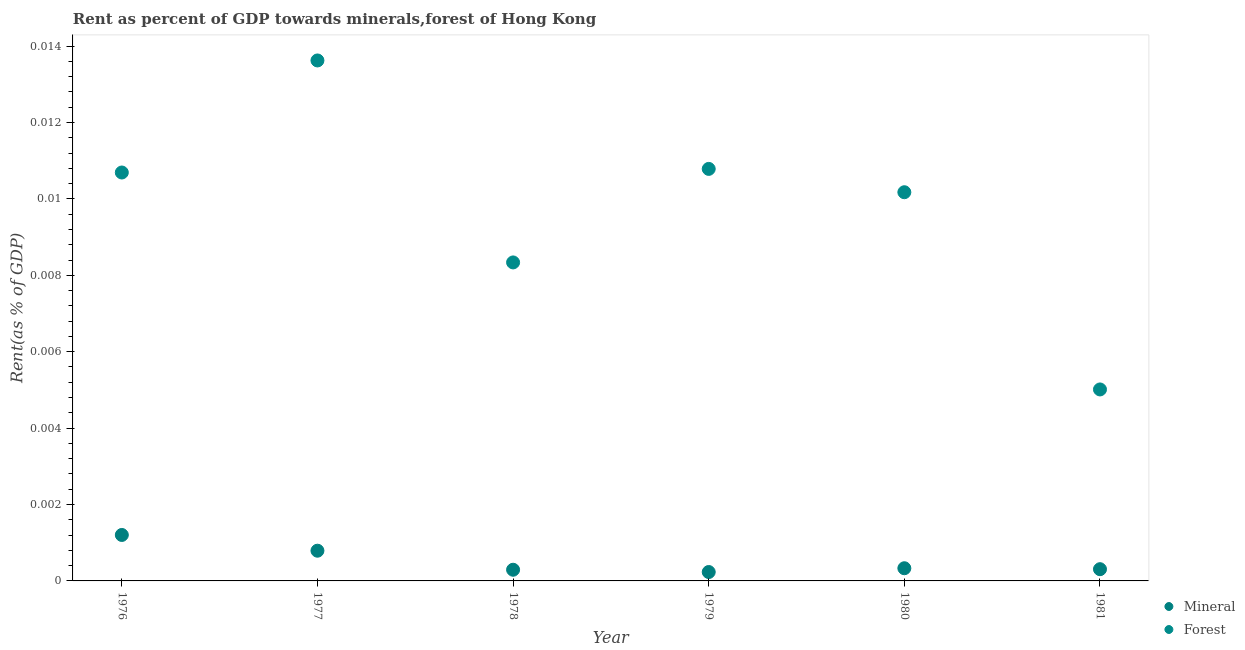How many different coloured dotlines are there?
Provide a succinct answer. 2. Is the number of dotlines equal to the number of legend labels?
Give a very brief answer. Yes. What is the forest rent in 1977?
Make the answer very short. 0.01. Across all years, what is the maximum mineral rent?
Offer a terse response. 0. Across all years, what is the minimum forest rent?
Make the answer very short. 0.01. What is the total mineral rent in the graph?
Give a very brief answer. 0. What is the difference between the mineral rent in 1978 and that in 1981?
Provide a short and direct response. -1.468707399487299e-5. What is the difference between the forest rent in 1978 and the mineral rent in 1980?
Ensure brevity in your answer.  0.01. What is the average forest rent per year?
Offer a terse response. 0.01. In the year 1981, what is the difference between the mineral rent and forest rent?
Make the answer very short. -0. In how many years, is the forest rent greater than 0.0072 %?
Ensure brevity in your answer.  5. What is the ratio of the forest rent in 1976 to that in 1980?
Your answer should be compact. 1.05. Is the mineral rent in 1978 less than that in 1980?
Your response must be concise. Yes. Is the difference between the forest rent in 1977 and 1980 greater than the difference between the mineral rent in 1977 and 1980?
Keep it short and to the point. Yes. What is the difference between the highest and the second highest mineral rent?
Your answer should be compact. 0. What is the difference between the highest and the lowest forest rent?
Give a very brief answer. 0.01. Is the mineral rent strictly greater than the forest rent over the years?
Offer a terse response. No. How many dotlines are there?
Ensure brevity in your answer.  2. What is the difference between two consecutive major ticks on the Y-axis?
Make the answer very short. 0. Does the graph contain grids?
Your answer should be very brief. No. How are the legend labels stacked?
Provide a short and direct response. Vertical. What is the title of the graph?
Offer a very short reply. Rent as percent of GDP towards minerals,forest of Hong Kong. What is the label or title of the X-axis?
Your answer should be very brief. Year. What is the label or title of the Y-axis?
Offer a very short reply. Rent(as % of GDP). What is the Rent(as % of GDP) in Mineral in 1976?
Provide a succinct answer. 0. What is the Rent(as % of GDP) in Forest in 1976?
Provide a short and direct response. 0.01. What is the Rent(as % of GDP) in Mineral in 1977?
Keep it short and to the point. 0. What is the Rent(as % of GDP) of Forest in 1977?
Keep it short and to the point. 0.01. What is the Rent(as % of GDP) of Mineral in 1978?
Provide a succinct answer. 0. What is the Rent(as % of GDP) of Forest in 1978?
Provide a short and direct response. 0.01. What is the Rent(as % of GDP) in Mineral in 1979?
Offer a very short reply. 0. What is the Rent(as % of GDP) of Forest in 1979?
Offer a terse response. 0.01. What is the Rent(as % of GDP) in Mineral in 1980?
Provide a short and direct response. 0. What is the Rent(as % of GDP) in Forest in 1980?
Your response must be concise. 0.01. What is the Rent(as % of GDP) in Mineral in 1981?
Offer a terse response. 0. What is the Rent(as % of GDP) of Forest in 1981?
Offer a terse response. 0.01. Across all years, what is the maximum Rent(as % of GDP) in Mineral?
Make the answer very short. 0. Across all years, what is the maximum Rent(as % of GDP) in Forest?
Keep it short and to the point. 0.01. Across all years, what is the minimum Rent(as % of GDP) in Mineral?
Provide a short and direct response. 0. Across all years, what is the minimum Rent(as % of GDP) of Forest?
Give a very brief answer. 0.01. What is the total Rent(as % of GDP) of Mineral in the graph?
Your answer should be very brief. 0. What is the total Rent(as % of GDP) in Forest in the graph?
Provide a short and direct response. 0.06. What is the difference between the Rent(as % of GDP) of Mineral in 1976 and that in 1977?
Offer a terse response. 0. What is the difference between the Rent(as % of GDP) in Forest in 1976 and that in 1977?
Keep it short and to the point. -0. What is the difference between the Rent(as % of GDP) in Mineral in 1976 and that in 1978?
Ensure brevity in your answer.  0. What is the difference between the Rent(as % of GDP) in Forest in 1976 and that in 1978?
Offer a very short reply. 0. What is the difference between the Rent(as % of GDP) of Mineral in 1976 and that in 1979?
Offer a terse response. 0. What is the difference between the Rent(as % of GDP) in Forest in 1976 and that in 1979?
Give a very brief answer. -0. What is the difference between the Rent(as % of GDP) of Mineral in 1976 and that in 1980?
Give a very brief answer. 0. What is the difference between the Rent(as % of GDP) in Forest in 1976 and that in 1980?
Provide a short and direct response. 0. What is the difference between the Rent(as % of GDP) of Mineral in 1976 and that in 1981?
Provide a short and direct response. 0. What is the difference between the Rent(as % of GDP) of Forest in 1976 and that in 1981?
Give a very brief answer. 0.01. What is the difference between the Rent(as % of GDP) of Forest in 1977 and that in 1978?
Your answer should be very brief. 0.01. What is the difference between the Rent(as % of GDP) in Mineral in 1977 and that in 1979?
Make the answer very short. 0. What is the difference between the Rent(as % of GDP) in Forest in 1977 and that in 1979?
Provide a short and direct response. 0. What is the difference between the Rent(as % of GDP) of Forest in 1977 and that in 1980?
Your answer should be compact. 0. What is the difference between the Rent(as % of GDP) in Mineral in 1977 and that in 1981?
Ensure brevity in your answer.  0. What is the difference between the Rent(as % of GDP) of Forest in 1977 and that in 1981?
Give a very brief answer. 0.01. What is the difference between the Rent(as % of GDP) in Forest in 1978 and that in 1979?
Your answer should be compact. -0. What is the difference between the Rent(as % of GDP) of Forest in 1978 and that in 1980?
Offer a terse response. -0. What is the difference between the Rent(as % of GDP) of Mineral in 1978 and that in 1981?
Your answer should be very brief. -0. What is the difference between the Rent(as % of GDP) in Forest in 1978 and that in 1981?
Provide a succinct answer. 0. What is the difference between the Rent(as % of GDP) of Mineral in 1979 and that in 1980?
Make the answer very short. -0. What is the difference between the Rent(as % of GDP) in Forest in 1979 and that in 1980?
Provide a succinct answer. 0. What is the difference between the Rent(as % of GDP) of Mineral in 1979 and that in 1981?
Your response must be concise. -0. What is the difference between the Rent(as % of GDP) of Forest in 1979 and that in 1981?
Offer a terse response. 0.01. What is the difference between the Rent(as % of GDP) of Forest in 1980 and that in 1981?
Offer a terse response. 0.01. What is the difference between the Rent(as % of GDP) in Mineral in 1976 and the Rent(as % of GDP) in Forest in 1977?
Ensure brevity in your answer.  -0.01. What is the difference between the Rent(as % of GDP) in Mineral in 1976 and the Rent(as % of GDP) in Forest in 1978?
Provide a short and direct response. -0.01. What is the difference between the Rent(as % of GDP) in Mineral in 1976 and the Rent(as % of GDP) in Forest in 1979?
Offer a very short reply. -0.01. What is the difference between the Rent(as % of GDP) in Mineral in 1976 and the Rent(as % of GDP) in Forest in 1980?
Provide a short and direct response. -0.01. What is the difference between the Rent(as % of GDP) in Mineral in 1976 and the Rent(as % of GDP) in Forest in 1981?
Your answer should be very brief. -0. What is the difference between the Rent(as % of GDP) of Mineral in 1977 and the Rent(as % of GDP) of Forest in 1978?
Your answer should be very brief. -0.01. What is the difference between the Rent(as % of GDP) in Mineral in 1977 and the Rent(as % of GDP) in Forest in 1979?
Give a very brief answer. -0.01. What is the difference between the Rent(as % of GDP) of Mineral in 1977 and the Rent(as % of GDP) of Forest in 1980?
Ensure brevity in your answer.  -0.01. What is the difference between the Rent(as % of GDP) in Mineral in 1977 and the Rent(as % of GDP) in Forest in 1981?
Offer a very short reply. -0. What is the difference between the Rent(as % of GDP) of Mineral in 1978 and the Rent(as % of GDP) of Forest in 1979?
Ensure brevity in your answer.  -0.01. What is the difference between the Rent(as % of GDP) in Mineral in 1978 and the Rent(as % of GDP) in Forest in 1980?
Ensure brevity in your answer.  -0.01. What is the difference between the Rent(as % of GDP) of Mineral in 1978 and the Rent(as % of GDP) of Forest in 1981?
Your answer should be very brief. -0. What is the difference between the Rent(as % of GDP) in Mineral in 1979 and the Rent(as % of GDP) in Forest in 1980?
Offer a very short reply. -0.01. What is the difference between the Rent(as % of GDP) of Mineral in 1979 and the Rent(as % of GDP) of Forest in 1981?
Offer a very short reply. -0. What is the difference between the Rent(as % of GDP) of Mineral in 1980 and the Rent(as % of GDP) of Forest in 1981?
Your answer should be very brief. -0. What is the average Rent(as % of GDP) of Mineral per year?
Offer a very short reply. 0. What is the average Rent(as % of GDP) in Forest per year?
Offer a very short reply. 0.01. In the year 1976, what is the difference between the Rent(as % of GDP) in Mineral and Rent(as % of GDP) in Forest?
Give a very brief answer. -0.01. In the year 1977, what is the difference between the Rent(as % of GDP) of Mineral and Rent(as % of GDP) of Forest?
Keep it short and to the point. -0.01. In the year 1978, what is the difference between the Rent(as % of GDP) in Mineral and Rent(as % of GDP) in Forest?
Give a very brief answer. -0.01. In the year 1979, what is the difference between the Rent(as % of GDP) in Mineral and Rent(as % of GDP) in Forest?
Your answer should be compact. -0.01. In the year 1980, what is the difference between the Rent(as % of GDP) of Mineral and Rent(as % of GDP) of Forest?
Your answer should be very brief. -0.01. In the year 1981, what is the difference between the Rent(as % of GDP) of Mineral and Rent(as % of GDP) of Forest?
Keep it short and to the point. -0. What is the ratio of the Rent(as % of GDP) of Mineral in 1976 to that in 1977?
Keep it short and to the point. 1.52. What is the ratio of the Rent(as % of GDP) of Forest in 1976 to that in 1977?
Your response must be concise. 0.78. What is the ratio of the Rent(as % of GDP) of Mineral in 1976 to that in 1978?
Your answer should be compact. 4.11. What is the ratio of the Rent(as % of GDP) in Forest in 1976 to that in 1978?
Keep it short and to the point. 1.28. What is the ratio of the Rent(as % of GDP) in Mineral in 1976 to that in 1979?
Provide a short and direct response. 5.16. What is the ratio of the Rent(as % of GDP) in Mineral in 1976 to that in 1980?
Ensure brevity in your answer.  3.62. What is the ratio of the Rent(as % of GDP) in Forest in 1976 to that in 1980?
Provide a short and direct response. 1.05. What is the ratio of the Rent(as % of GDP) of Mineral in 1976 to that in 1981?
Provide a short and direct response. 3.92. What is the ratio of the Rent(as % of GDP) in Forest in 1976 to that in 1981?
Your answer should be compact. 2.13. What is the ratio of the Rent(as % of GDP) of Mineral in 1977 to that in 1978?
Keep it short and to the point. 2.7. What is the ratio of the Rent(as % of GDP) in Forest in 1977 to that in 1978?
Ensure brevity in your answer.  1.63. What is the ratio of the Rent(as % of GDP) of Mineral in 1977 to that in 1979?
Your answer should be very brief. 3.39. What is the ratio of the Rent(as % of GDP) in Forest in 1977 to that in 1979?
Offer a terse response. 1.26. What is the ratio of the Rent(as % of GDP) in Mineral in 1977 to that in 1980?
Keep it short and to the point. 2.38. What is the ratio of the Rent(as % of GDP) in Forest in 1977 to that in 1980?
Your answer should be very brief. 1.34. What is the ratio of the Rent(as % of GDP) in Mineral in 1977 to that in 1981?
Your answer should be compact. 2.57. What is the ratio of the Rent(as % of GDP) in Forest in 1977 to that in 1981?
Your answer should be compact. 2.72. What is the ratio of the Rent(as % of GDP) in Mineral in 1978 to that in 1979?
Provide a short and direct response. 1.26. What is the ratio of the Rent(as % of GDP) in Forest in 1978 to that in 1979?
Keep it short and to the point. 0.77. What is the ratio of the Rent(as % of GDP) of Mineral in 1978 to that in 1980?
Offer a very short reply. 0.88. What is the ratio of the Rent(as % of GDP) of Forest in 1978 to that in 1980?
Give a very brief answer. 0.82. What is the ratio of the Rent(as % of GDP) of Mineral in 1978 to that in 1981?
Make the answer very short. 0.95. What is the ratio of the Rent(as % of GDP) in Forest in 1978 to that in 1981?
Ensure brevity in your answer.  1.66. What is the ratio of the Rent(as % of GDP) of Mineral in 1979 to that in 1980?
Your answer should be compact. 0.7. What is the ratio of the Rent(as % of GDP) of Forest in 1979 to that in 1980?
Offer a terse response. 1.06. What is the ratio of the Rent(as % of GDP) of Mineral in 1979 to that in 1981?
Provide a short and direct response. 0.76. What is the ratio of the Rent(as % of GDP) in Forest in 1979 to that in 1981?
Your response must be concise. 2.15. What is the ratio of the Rent(as % of GDP) of Mineral in 1980 to that in 1981?
Your answer should be very brief. 1.08. What is the ratio of the Rent(as % of GDP) in Forest in 1980 to that in 1981?
Ensure brevity in your answer.  2.03. What is the difference between the highest and the second highest Rent(as % of GDP) of Forest?
Your response must be concise. 0. What is the difference between the highest and the lowest Rent(as % of GDP) of Mineral?
Give a very brief answer. 0. What is the difference between the highest and the lowest Rent(as % of GDP) of Forest?
Provide a succinct answer. 0.01. 